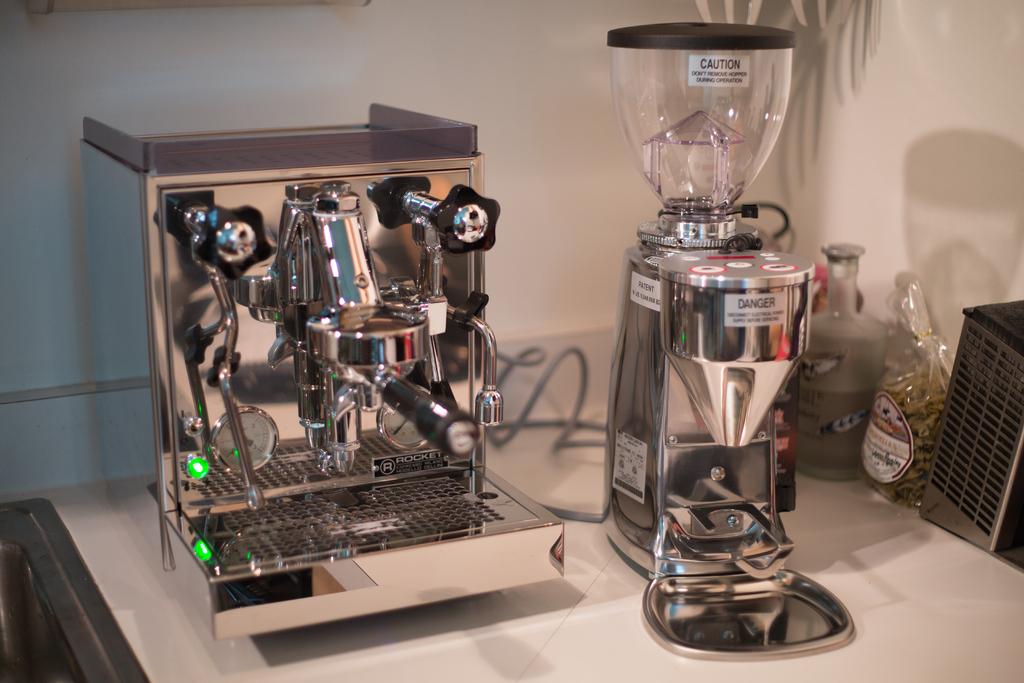What is the word of warning on the blender?
Your answer should be compact. Danger. What's the brand name of this espresso machine?
Offer a very short reply. Rocket. 